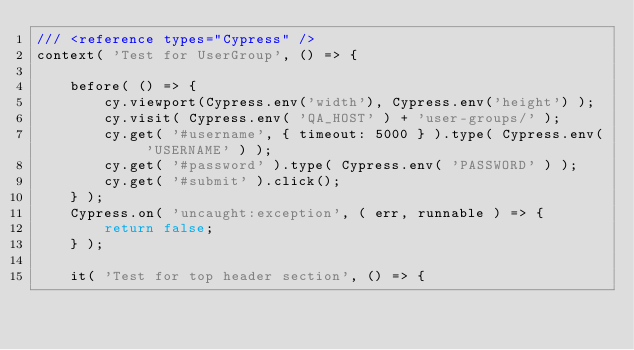<code> <loc_0><loc_0><loc_500><loc_500><_JavaScript_>/// <reference types="Cypress" />
context( 'Test for UserGroup', () => {

    before( () => {
        cy.viewport(Cypress.env('width'), Cypress.env('height') );
        cy.visit( Cypress.env( 'QA_HOST' ) + 'user-groups/' );
        cy.get( '#username', { timeout: 5000 } ).type( Cypress.env( 'USERNAME' ) );
        cy.get( '#password' ).type( Cypress.env( 'PASSWORD' ) );
        cy.get( '#submit' ).click();
    } );
    Cypress.on( 'uncaught:exception', ( err, runnable ) => {
        return false;
    } );

    it( 'Test for top header section', () => {</code> 